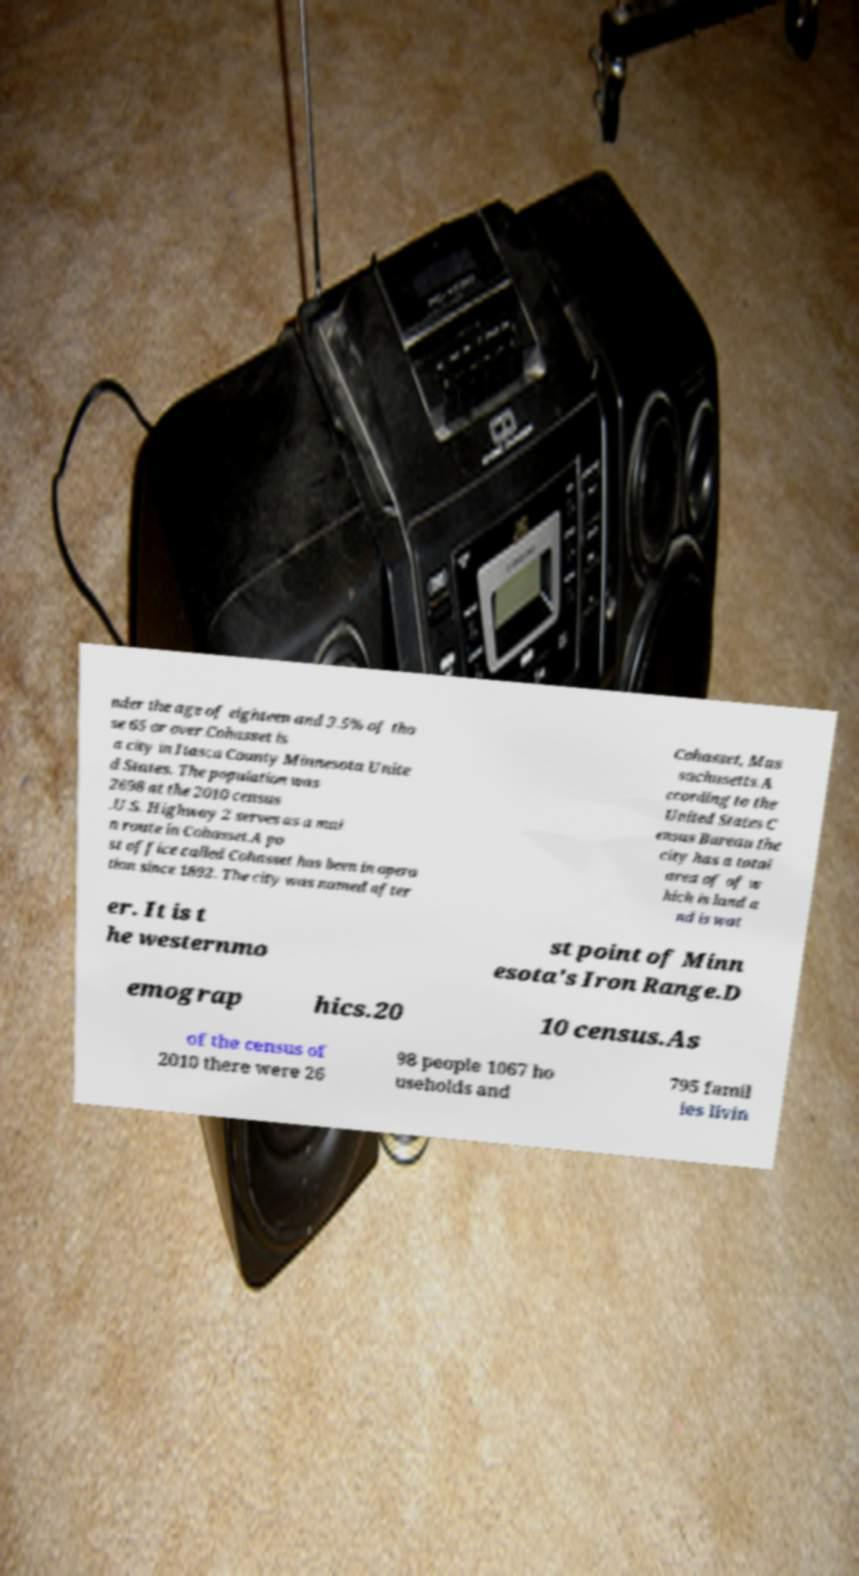Can you accurately transcribe the text from the provided image for me? nder the age of eighteen and 3.5% of tho se 65 or over.Cohasset is a city in Itasca County Minnesota Unite d States. The population was 2698 at the 2010 census .U.S. Highway 2 serves as a mai n route in Cohasset.A po st office called Cohasset has been in opera tion since 1892. The city was named after Cohasset, Mas sachusetts.A ccording to the United States C ensus Bureau the city has a total area of of w hich is land a nd is wat er. It is t he westernmo st point of Minn esota's Iron Range.D emograp hics.20 10 census.As of the census of 2010 there were 26 98 people 1067 ho useholds and 795 famil ies livin 